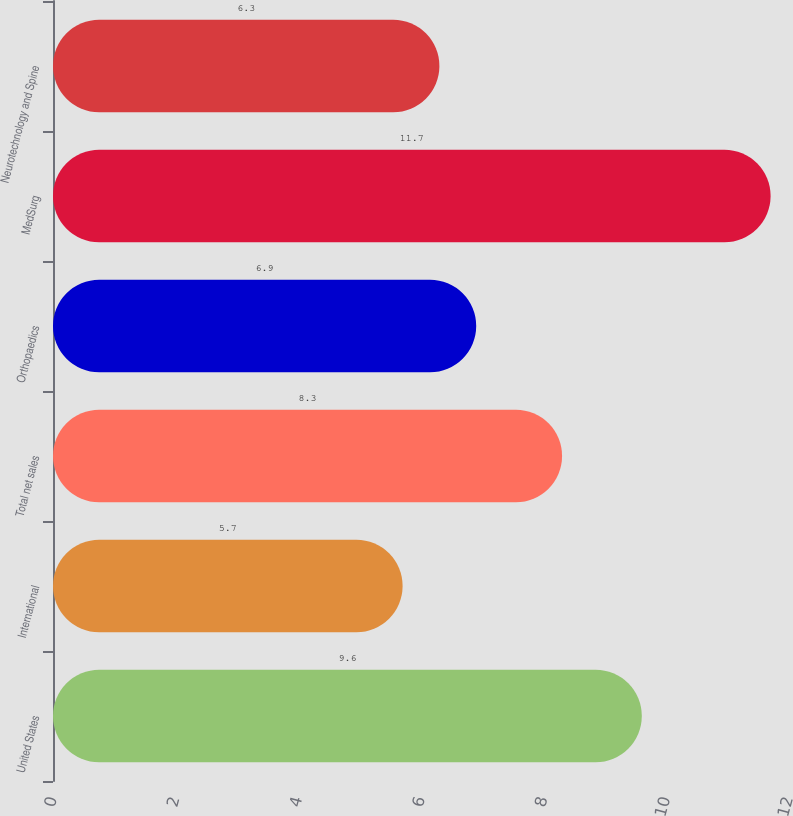Convert chart to OTSL. <chart><loc_0><loc_0><loc_500><loc_500><bar_chart><fcel>United States<fcel>International<fcel>Total net sales<fcel>Orthopaedics<fcel>MedSurg<fcel>Neurotechnology and Spine<nl><fcel>9.6<fcel>5.7<fcel>8.3<fcel>6.9<fcel>11.7<fcel>6.3<nl></chart> 